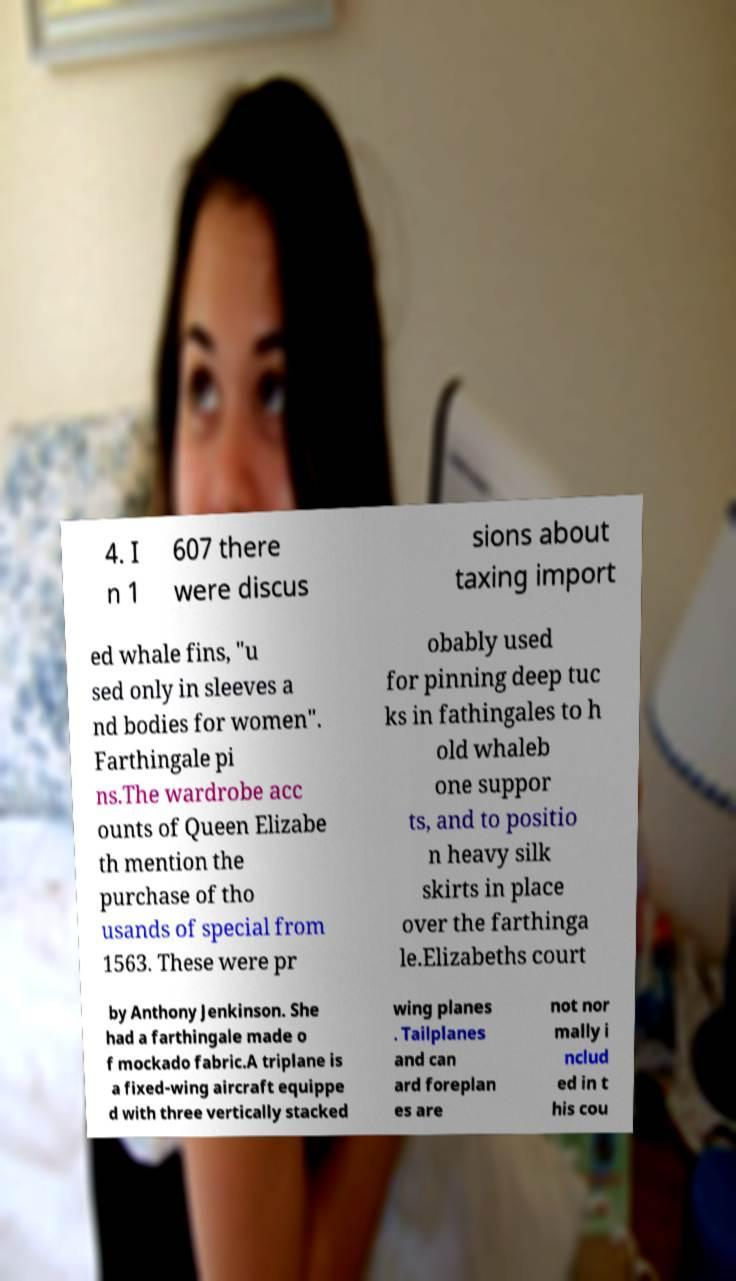What messages or text are displayed in this image? I need them in a readable, typed format. 4. I n 1 607 there were discus sions about taxing import ed whale fins, "u sed only in sleeves a nd bodies for women". Farthingale pi ns.The wardrobe acc ounts of Queen Elizabe th mention the purchase of tho usands of special from 1563. These were pr obably used for pinning deep tuc ks in fathingales to h old whaleb one suppor ts, and to positio n heavy silk skirts in place over the farthinga le.Elizabeths court by Anthony Jenkinson. She had a farthingale made o f mockado fabric.A triplane is a fixed-wing aircraft equippe d with three vertically stacked wing planes . Tailplanes and can ard foreplan es are not nor mally i nclud ed in t his cou 